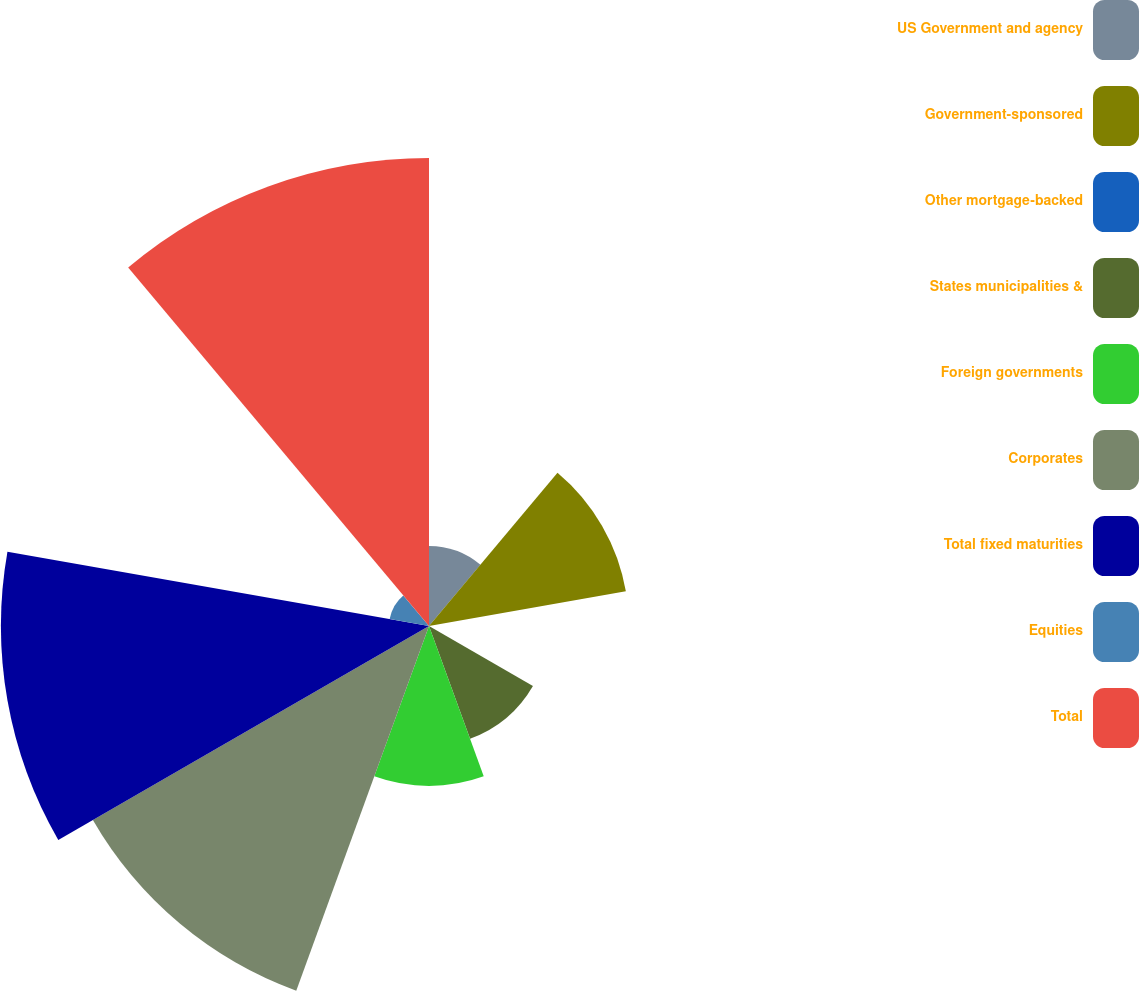Convert chart to OTSL. <chart><loc_0><loc_0><loc_500><loc_500><pie_chart><fcel>US Government and agency<fcel>Government-sponsored<fcel>Other mortgage-backed<fcel>States municipalities &<fcel>Foreign governments<fcel>Corporates<fcel>Total fixed maturities<fcel>Equities<fcel>Total<nl><fcel>4.25%<fcel>10.61%<fcel>0.0%<fcel>6.37%<fcel>8.49%<fcel>20.6%<fcel>22.72%<fcel>2.12%<fcel>24.84%<nl></chart> 